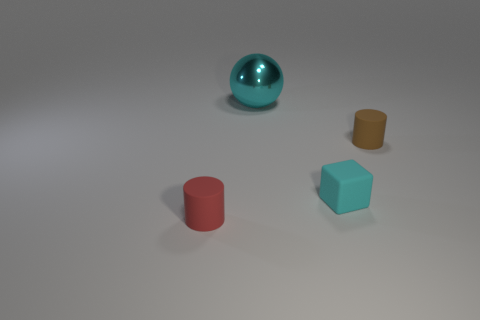Add 4 small brown objects. How many objects exist? 8 Subtract all cubes. How many objects are left? 3 Subtract all blocks. Subtract all purple metal cylinders. How many objects are left? 3 Add 4 tiny cyan rubber cubes. How many tiny cyan rubber cubes are left? 5 Add 2 large rubber spheres. How many large rubber spheres exist? 2 Subtract 0 brown cubes. How many objects are left? 4 